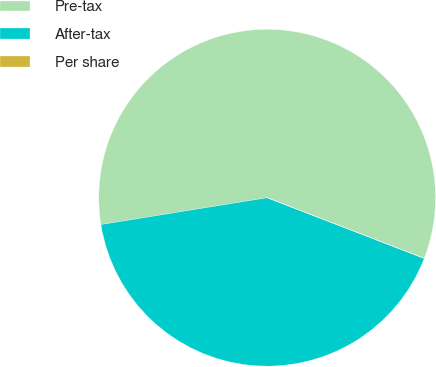Convert chart. <chart><loc_0><loc_0><loc_500><loc_500><pie_chart><fcel>Pre-tax<fcel>After-tax<fcel>Per share<nl><fcel>58.4%<fcel>41.58%<fcel>0.02%<nl></chart> 